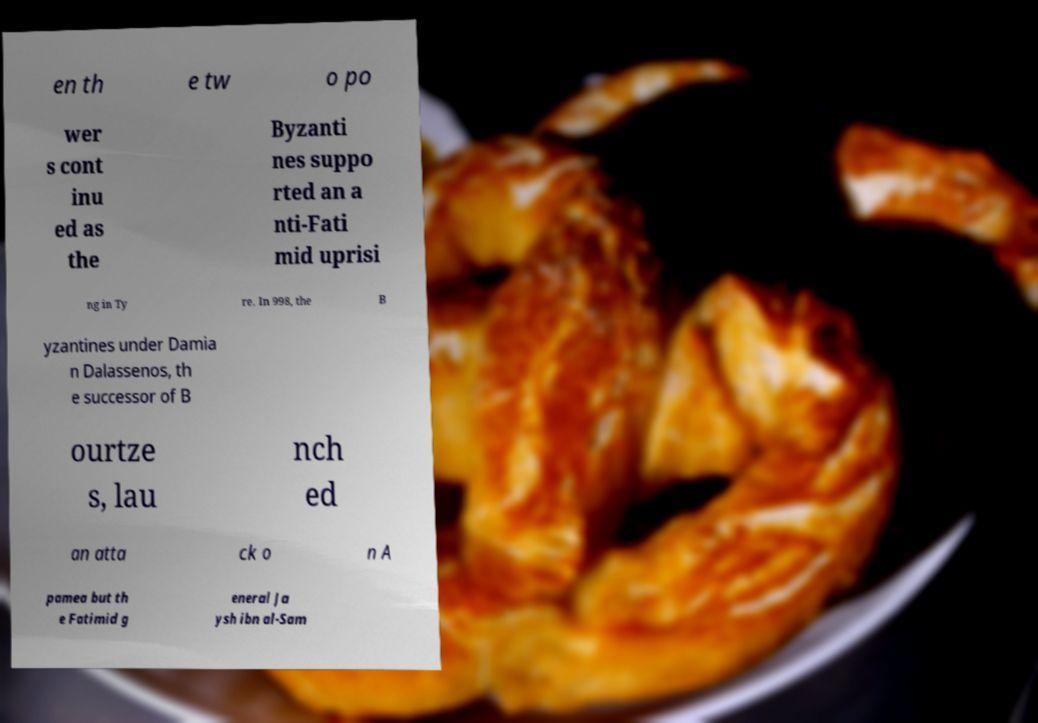Can you read and provide the text displayed in the image?This photo seems to have some interesting text. Can you extract and type it out for me? en th e tw o po wer s cont inu ed as the Byzanti nes suppo rted an a nti-Fati mid uprisi ng in Ty re. In 998, the B yzantines under Damia n Dalassenos, th e successor of B ourtze s, lau nch ed an atta ck o n A pamea but th e Fatimid g eneral Ja ysh ibn al-Sam 